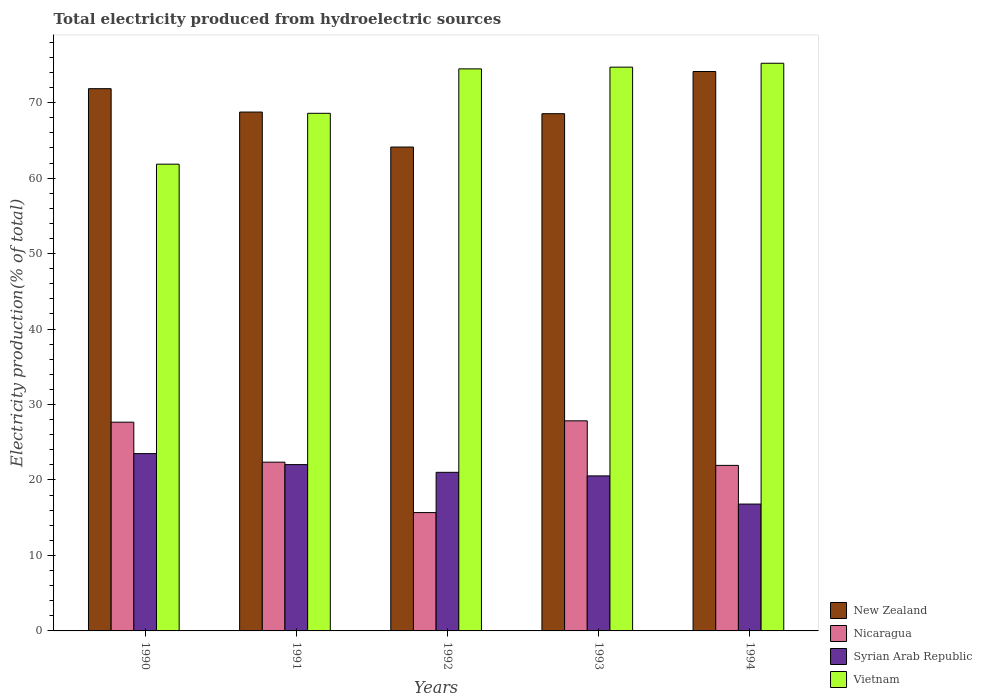How many different coloured bars are there?
Ensure brevity in your answer.  4. Are the number of bars on each tick of the X-axis equal?
Provide a succinct answer. Yes. How many bars are there on the 5th tick from the right?
Offer a very short reply. 4. What is the label of the 5th group of bars from the left?
Offer a very short reply. 1994. In how many cases, is the number of bars for a given year not equal to the number of legend labels?
Make the answer very short. 0. What is the total electricity produced in New Zealand in 1993?
Keep it short and to the point. 68.54. Across all years, what is the maximum total electricity produced in New Zealand?
Your answer should be compact. 74.13. Across all years, what is the minimum total electricity produced in New Zealand?
Give a very brief answer. 64.12. What is the total total electricity produced in Syrian Arab Republic in the graph?
Ensure brevity in your answer.  103.9. What is the difference between the total electricity produced in Nicaragua in 1990 and that in 1992?
Provide a succinct answer. 11.98. What is the difference between the total electricity produced in New Zealand in 1994 and the total electricity produced in Vietnam in 1990?
Provide a short and direct response. 12.28. What is the average total electricity produced in Nicaragua per year?
Give a very brief answer. 23.1. In the year 1993, what is the difference between the total electricity produced in Nicaragua and total electricity produced in Vietnam?
Ensure brevity in your answer.  -46.87. In how many years, is the total electricity produced in Syrian Arab Republic greater than 42 %?
Make the answer very short. 0. What is the ratio of the total electricity produced in New Zealand in 1992 to that in 1993?
Offer a very short reply. 0.94. What is the difference between the highest and the second highest total electricity produced in Syrian Arab Republic?
Keep it short and to the point. 1.46. What is the difference between the highest and the lowest total electricity produced in Nicaragua?
Ensure brevity in your answer.  12.16. In how many years, is the total electricity produced in Nicaragua greater than the average total electricity produced in Nicaragua taken over all years?
Your answer should be very brief. 2. Is the sum of the total electricity produced in Syrian Arab Republic in 1990 and 1992 greater than the maximum total electricity produced in Vietnam across all years?
Give a very brief answer. No. Is it the case that in every year, the sum of the total electricity produced in New Zealand and total electricity produced in Nicaragua is greater than the sum of total electricity produced in Vietnam and total electricity produced in Syrian Arab Republic?
Provide a succinct answer. No. What does the 2nd bar from the left in 1991 represents?
Provide a short and direct response. Nicaragua. What does the 1st bar from the right in 1993 represents?
Make the answer very short. Vietnam. How many years are there in the graph?
Provide a short and direct response. 5. Are the values on the major ticks of Y-axis written in scientific E-notation?
Ensure brevity in your answer.  No. Does the graph contain grids?
Provide a succinct answer. No. Where does the legend appear in the graph?
Give a very brief answer. Bottom right. How are the legend labels stacked?
Keep it short and to the point. Vertical. What is the title of the graph?
Offer a very short reply. Total electricity produced from hydroelectric sources. What is the label or title of the X-axis?
Make the answer very short. Years. What is the Electricity production(% of total) in New Zealand in 1990?
Offer a terse response. 71.85. What is the Electricity production(% of total) in Nicaragua in 1990?
Offer a very short reply. 27.66. What is the Electricity production(% of total) of Syrian Arab Republic in 1990?
Provide a short and direct response. 23.49. What is the Electricity production(% of total) of Vietnam in 1990?
Give a very brief answer. 61.85. What is the Electricity production(% of total) in New Zealand in 1991?
Offer a terse response. 68.75. What is the Electricity production(% of total) in Nicaragua in 1991?
Ensure brevity in your answer.  22.36. What is the Electricity production(% of total) in Syrian Arab Republic in 1991?
Your response must be concise. 22.04. What is the Electricity production(% of total) in Vietnam in 1991?
Your answer should be compact. 68.59. What is the Electricity production(% of total) of New Zealand in 1992?
Give a very brief answer. 64.12. What is the Electricity production(% of total) in Nicaragua in 1992?
Give a very brief answer. 15.68. What is the Electricity production(% of total) in Syrian Arab Republic in 1992?
Offer a very short reply. 21.02. What is the Electricity production(% of total) in Vietnam in 1992?
Provide a short and direct response. 74.48. What is the Electricity production(% of total) of New Zealand in 1993?
Make the answer very short. 68.54. What is the Electricity production(% of total) of Nicaragua in 1993?
Keep it short and to the point. 27.84. What is the Electricity production(% of total) in Syrian Arab Republic in 1993?
Make the answer very short. 20.54. What is the Electricity production(% of total) in Vietnam in 1993?
Keep it short and to the point. 74.7. What is the Electricity production(% of total) of New Zealand in 1994?
Provide a short and direct response. 74.13. What is the Electricity production(% of total) in Nicaragua in 1994?
Your response must be concise. 21.94. What is the Electricity production(% of total) of Syrian Arab Republic in 1994?
Provide a short and direct response. 16.81. What is the Electricity production(% of total) in Vietnam in 1994?
Offer a very short reply. 75.22. Across all years, what is the maximum Electricity production(% of total) of New Zealand?
Offer a very short reply. 74.13. Across all years, what is the maximum Electricity production(% of total) in Nicaragua?
Make the answer very short. 27.84. Across all years, what is the maximum Electricity production(% of total) in Syrian Arab Republic?
Make the answer very short. 23.49. Across all years, what is the maximum Electricity production(% of total) of Vietnam?
Your response must be concise. 75.22. Across all years, what is the minimum Electricity production(% of total) of New Zealand?
Give a very brief answer. 64.12. Across all years, what is the minimum Electricity production(% of total) in Nicaragua?
Your answer should be compact. 15.68. Across all years, what is the minimum Electricity production(% of total) of Syrian Arab Republic?
Your answer should be very brief. 16.81. Across all years, what is the minimum Electricity production(% of total) of Vietnam?
Offer a very short reply. 61.85. What is the total Electricity production(% of total) in New Zealand in the graph?
Ensure brevity in your answer.  347.39. What is the total Electricity production(% of total) of Nicaragua in the graph?
Provide a short and direct response. 115.48. What is the total Electricity production(% of total) in Syrian Arab Republic in the graph?
Ensure brevity in your answer.  103.9. What is the total Electricity production(% of total) in Vietnam in the graph?
Your answer should be compact. 354.84. What is the difference between the Electricity production(% of total) in New Zealand in 1990 and that in 1991?
Offer a very short reply. 3.1. What is the difference between the Electricity production(% of total) in Nicaragua in 1990 and that in 1991?
Offer a terse response. 5.3. What is the difference between the Electricity production(% of total) of Syrian Arab Republic in 1990 and that in 1991?
Provide a succinct answer. 1.46. What is the difference between the Electricity production(% of total) in Vietnam in 1990 and that in 1991?
Your answer should be very brief. -6.74. What is the difference between the Electricity production(% of total) in New Zealand in 1990 and that in 1992?
Make the answer very short. 7.73. What is the difference between the Electricity production(% of total) in Nicaragua in 1990 and that in 1992?
Give a very brief answer. 11.98. What is the difference between the Electricity production(% of total) of Syrian Arab Republic in 1990 and that in 1992?
Provide a succinct answer. 2.48. What is the difference between the Electricity production(% of total) in Vietnam in 1990 and that in 1992?
Provide a succinct answer. -12.63. What is the difference between the Electricity production(% of total) in New Zealand in 1990 and that in 1993?
Offer a terse response. 3.31. What is the difference between the Electricity production(% of total) of Nicaragua in 1990 and that in 1993?
Offer a very short reply. -0.18. What is the difference between the Electricity production(% of total) in Syrian Arab Republic in 1990 and that in 1993?
Give a very brief answer. 2.95. What is the difference between the Electricity production(% of total) in Vietnam in 1990 and that in 1993?
Your response must be concise. -12.86. What is the difference between the Electricity production(% of total) of New Zealand in 1990 and that in 1994?
Give a very brief answer. -2.28. What is the difference between the Electricity production(% of total) of Nicaragua in 1990 and that in 1994?
Ensure brevity in your answer.  5.72. What is the difference between the Electricity production(% of total) in Syrian Arab Republic in 1990 and that in 1994?
Offer a very short reply. 6.69. What is the difference between the Electricity production(% of total) in Vietnam in 1990 and that in 1994?
Your answer should be very brief. -13.37. What is the difference between the Electricity production(% of total) in New Zealand in 1991 and that in 1992?
Your answer should be compact. 4.63. What is the difference between the Electricity production(% of total) of Nicaragua in 1991 and that in 1992?
Ensure brevity in your answer.  6.68. What is the difference between the Electricity production(% of total) in Syrian Arab Republic in 1991 and that in 1992?
Your answer should be very brief. 1.02. What is the difference between the Electricity production(% of total) of Vietnam in 1991 and that in 1992?
Ensure brevity in your answer.  -5.89. What is the difference between the Electricity production(% of total) of New Zealand in 1991 and that in 1993?
Offer a very short reply. 0.22. What is the difference between the Electricity production(% of total) of Nicaragua in 1991 and that in 1993?
Give a very brief answer. -5.48. What is the difference between the Electricity production(% of total) in Syrian Arab Republic in 1991 and that in 1993?
Provide a short and direct response. 1.5. What is the difference between the Electricity production(% of total) in Vietnam in 1991 and that in 1993?
Give a very brief answer. -6.12. What is the difference between the Electricity production(% of total) of New Zealand in 1991 and that in 1994?
Your answer should be very brief. -5.37. What is the difference between the Electricity production(% of total) of Nicaragua in 1991 and that in 1994?
Offer a terse response. 0.43. What is the difference between the Electricity production(% of total) of Syrian Arab Republic in 1991 and that in 1994?
Offer a terse response. 5.23. What is the difference between the Electricity production(% of total) of Vietnam in 1991 and that in 1994?
Your response must be concise. -6.63. What is the difference between the Electricity production(% of total) in New Zealand in 1992 and that in 1993?
Ensure brevity in your answer.  -4.42. What is the difference between the Electricity production(% of total) in Nicaragua in 1992 and that in 1993?
Give a very brief answer. -12.16. What is the difference between the Electricity production(% of total) in Syrian Arab Republic in 1992 and that in 1993?
Your answer should be compact. 0.47. What is the difference between the Electricity production(% of total) of Vietnam in 1992 and that in 1993?
Your answer should be very brief. -0.23. What is the difference between the Electricity production(% of total) of New Zealand in 1992 and that in 1994?
Ensure brevity in your answer.  -10.01. What is the difference between the Electricity production(% of total) in Nicaragua in 1992 and that in 1994?
Provide a short and direct response. -6.26. What is the difference between the Electricity production(% of total) of Syrian Arab Republic in 1992 and that in 1994?
Provide a short and direct response. 4.21. What is the difference between the Electricity production(% of total) in Vietnam in 1992 and that in 1994?
Your response must be concise. -0.74. What is the difference between the Electricity production(% of total) in New Zealand in 1993 and that in 1994?
Your answer should be compact. -5.59. What is the difference between the Electricity production(% of total) of Nicaragua in 1993 and that in 1994?
Make the answer very short. 5.9. What is the difference between the Electricity production(% of total) of Syrian Arab Republic in 1993 and that in 1994?
Keep it short and to the point. 3.73. What is the difference between the Electricity production(% of total) of Vietnam in 1993 and that in 1994?
Offer a terse response. -0.52. What is the difference between the Electricity production(% of total) in New Zealand in 1990 and the Electricity production(% of total) in Nicaragua in 1991?
Your answer should be compact. 49.49. What is the difference between the Electricity production(% of total) in New Zealand in 1990 and the Electricity production(% of total) in Syrian Arab Republic in 1991?
Give a very brief answer. 49.81. What is the difference between the Electricity production(% of total) of New Zealand in 1990 and the Electricity production(% of total) of Vietnam in 1991?
Give a very brief answer. 3.26. What is the difference between the Electricity production(% of total) of Nicaragua in 1990 and the Electricity production(% of total) of Syrian Arab Republic in 1991?
Give a very brief answer. 5.62. What is the difference between the Electricity production(% of total) in Nicaragua in 1990 and the Electricity production(% of total) in Vietnam in 1991?
Make the answer very short. -40.93. What is the difference between the Electricity production(% of total) in Syrian Arab Republic in 1990 and the Electricity production(% of total) in Vietnam in 1991?
Your response must be concise. -45.09. What is the difference between the Electricity production(% of total) of New Zealand in 1990 and the Electricity production(% of total) of Nicaragua in 1992?
Keep it short and to the point. 56.17. What is the difference between the Electricity production(% of total) in New Zealand in 1990 and the Electricity production(% of total) in Syrian Arab Republic in 1992?
Keep it short and to the point. 50.84. What is the difference between the Electricity production(% of total) of New Zealand in 1990 and the Electricity production(% of total) of Vietnam in 1992?
Make the answer very short. -2.63. What is the difference between the Electricity production(% of total) of Nicaragua in 1990 and the Electricity production(% of total) of Syrian Arab Republic in 1992?
Keep it short and to the point. 6.64. What is the difference between the Electricity production(% of total) of Nicaragua in 1990 and the Electricity production(% of total) of Vietnam in 1992?
Provide a succinct answer. -46.82. What is the difference between the Electricity production(% of total) in Syrian Arab Republic in 1990 and the Electricity production(% of total) in Vietnam in 1992?
Make the answer very short. -50.98. What is the difference between the Electricity production(% of total) of New Zealand in 1990 and the Electricity production(% of total) of Nicaragua in 1993?
Give a very brief answer. 44.01. What is the difference between the Electricity production(% of total) in New Zealand in 1990 and the Electricity production(% of total) in Syrian Arab Republic in 1993?
Provide a succinct answer. 51.31. What is the difference between the Electricity production(% of total) of New Zealand in 1990 and the Electricity production(% of total) of Vietnam in 1993?
Keep it short and to the point. -2.85. What is the difference between the Electricity production(% of total) of Nicaragua in 1990 and the Electricity production(% of total) of Syrian Arab Republic in 1993?
Provide a short and direct response. 7.12. What is the difference between the Electricity production(% of total) of Nicaragua in 1990 and the Electricity production(% of total) of Vietnam in 1993?
Offer a terse response. -47.05. What is the difference between the Electricity production(% of total) of Syrian Arab Republic in 1990 and the Electricity production(% of total) of Vietnam in 1993?
Ensure brevity in your answer.  -51.21. What is the difference between the Electricity production(% of total) in New Zealand in 1990 and the Electricity production(% of total) in Nicaragua in 1994?
Offer a very short reply. 49.92. What is the difference between the Electricity production(% of total) of New Zealand in 1990 and the Electricity production(% of total) of Syrian Arab Republic in 1994?
Give a very brief answer. 55.04. What is the difference between the Electricity production(% of total) in New Zealand in 1990 and the Electricity production(% of total) in Vietnam in 1994?
Your response must be concise. -3.37. What is the difference between the Electricity production(% of total) of Nicaragua in 1990 and the Electricity production(% of total) of Syrian Arab Republic in 1994?
Make the answer very short. 10.85. What is the difference between the Electricity production(% of total) in Nicaragua in 1990 and the Electricity production(% of total) in Vietnam in 1994?
Give a very brief answer. -47.56. What is the difference between the Electricity production(% of total) of Syrian Arab Republic in 1990 and the Electricity production(% of total) of Vietnam in 1994?
Keep it short and to the point. -51.72. What is the difference between the Electricity production(% of total) of New Zealand in 1991 and the Electricity production(% of total) of Nicaragua in 1992?
Provide a succinct answer. 53.07. What is the difference between the Electricity production(% of total) in New Zealand in 1991 and the Electricity production(% of total) in Syrian Arab Republic in 1992?
Your answer should be compact. 47.74. What is the difference between the Electricity production(% of total) in New Zealand in 1991 and the Electricity production(% of total) in Vietnam in 1992?
Keep it short and to the point. -5.72. What is the difference between the Electricity production(% of total) in Nicaragua in 1991 and the Electricity production(% of total) in Syrian Arab Republic in 1992?
Offer a very short reply. 1.35. What is the difference between the Electricity production(% of total) of Nicaragua in 1991 and the Electricity production(% of total) of Vietnam in 1992?
Ensure brevity in your answer.  -52.11. What is the difference between the Electricity production(% of total) in Syrian Arab Republic in 1991 and the Electricity production(% of total) in Vietnam in 1992?
Ensure brevity in your answer.  -52.44. What is the difference between the Electricity production(% of total) of New Zealand in 1991 and the Electricity production(% of total) of Nicaragua in 1993?
Give a very brief answer. 40.91. What is the difference between the Electricity production(% of total) in New Zealand in 1991 and the Electricity production(% of total) in Syrian Arab Republic in 1993?
Your answer should be compact. 48.21. What is the difference between the Electricity production(% of total) in New Zealand in 1991 and the Electricity production(% of total) in Vietnam in 1993?
Offer a very short reply. -5.95. What is the difference between the Electricity production(% of total) of Nicaragua in 1991 and the Electricity production(% of total) of Syrian Arab Republic in 1993?
Your answer should be very brief. 1.82. What is the difference between the Electricity production(% of total) of Nicaragua in 1991 and the Electricity production(% of total) of Vietnam in 1993?
Your answer should be compact. -52.34. What is the difference between the Electricity production(% of total) of Syrian Arab Republic in 1991 and the Electricity production(% of total) of Vietnam in 1993?
Make the answer very short. -52.67. What is the difference between the Electricity production(% of total) of New Zealand in 1991 and the Electricity production(% of total) of Nicaragua in 1994?
Your response must be concise. 46.82. What is the difference between the Electricity production(% of total) of New Zealand in 1991 and the Electricity production(% of total) of Syrian Arab Republic in 1994?
Your answer should be very brief. 51.94. What is the difference between the Electricity production(% of total) in New Zealand in 1991 and the Electricity production(% of total) in Vietnam in 1994?
Give a very brief answer. -6.47. What is the difference between the Electricity production(% of total) of Nicaragua in 1991 and the Electricity production(% of total) of Syrian Arab Republic in 1994?
Your response must be concise. 5.55. What is the difference between the Electricity production(% of total) of Nicaragua in 1991 and the Electricity production(% of total) of Vietnam in 1994?
Ensure brevity in your answer.  -52.86. What is the difference between the Electricity production(% of total) of Syrian Arab Republic in 1991 and the Electricity production(% of total) of Vietnam in 1994?
Keep it short and to the point. -53.18. What is the difference between the Electricity production(% of total) in New Zealand in 1992 and the Electricity production(% of total) in Nicaragua in 1993?
Make the answer very short. 36.28. What is the difference between the Electricity production(% of total) in New Zealand in 1992 and the Electricity production(% of total) in Syrian Arab Republic in 1993?
Provide a short and direct response. 43.58. What is the difference between the Electricity production(% of total) in New Zealand in 1992 and the Electricity production(% of total) in Vietnam in 1993?
Your answer should be very brief. -10.59. What is the difference between the Electricity production(% of total) in Nicaragua in 1992 and the Electricity production(% of total) in Syrian Arab Republic in 1993?
Offer a very short reply. -4.86. What is the difference between the Electricity production(% of total) of Nicaragua in 1992 and the Electricity production(% of total) of Vietnam in 1993?
Offer a terse response. -59.02. What is the difference between the Electricity production(% of total) of Syrian Arab Republic in 1992 and the Electricity production(% of total) of Vietnam in 1993?
Offer a very short reply. -53.69. What is the difference between the Electricity production(% of total) in New Zealand in 1992 and the Electricity production(% of total) in Nicaragua in 1994?
Offer a terse response. 42.18. What is the difference between the Electricity production(% of total) of New Zealand in 1992 and the Electricity production(% of total) of Syrian Arab Republic in 1994?
Offer a very short reply. 47.31. What is the difference between the Electricity production(% of total) of New Zealand in 1992 and the Electricity production(% of total) of Vietnam in 1994?
Offer a very short reply. -11.1. What is the difference between the Electricity production(% of total) in Nicaragua in 1992 and the Electricity production(% of total) in Syrian Arab Republic in 1994?
Keep it short and to the point. -1.13. What is the difference between the Electricity production(% of total) in Nicaragua in 1992 and the Electricity production(% of total) in Vietnam in 1994?
Make the answer very short. -59.54. What is the difference between the Electricity production(% of total) of Syrian Arab Republic in 1992 and the Electricity production(% of total) of Vietnam in 1994?
Offer a terse response. -54.2. What is the difference between the Electricity production(% of total) of New Zealand in 1993 and the Electricity production(% of total) of Nicaragua in 1994?
Give a very brief answer. 46.6. What is the difference between the Electricity production(% of total) of New Zealand in 1993 and the Electricity production(% of total) of Syrian Arab Republic in 1994?
Make the answer very short. 51.73. What is the difference between the Electricity production(% of total) of New Zealand in 1993 and the Electricity production(% of total) of Vietnam in 1994?
Your answer should be compact. -6.68. What is the difference between the Electricity production(% of total) in Nicaragua in 1993 and the Electricity production(% of total) in Syrian Arab Republic in 1994?
Provide a short and direct response. 11.03. What is the difference between the Electricity production(% of total) of Nicaragua in 1993 and the Electricity production(% of total) of Vietnam in 1994?
Provide a succinct answer. -47.38. What is the difference between the Electricity production(% of total) of Syrian Arab Republic in 1993 and the Electricity production(% of total) of Vietnam in 1994?
Keep it short and to the point. -54.68. What is the average Electricity production(% of total) of New Zealand per year?
Offer a very short reply. 69.48. What is the average Electricity production(% of total) in Nicaragua per year?
Make the answer very short. 23.1. What is the average Electricity production(% of total) of Syrian Arab Republic per year?
Your answer should be very brief. 20.78. What is the average Electricity production(% of total) in Vietnam per year?
Keep it short and to the point. 70.97. In the year 1990, what is the difference between the Electricity production(% of total) in New Zealand and Electricity production(% of total) in Nicaragua?
Your answer should be very brief. 44.19. In the year 1990, what is the difference between the Electricity production(% of total) of New Zealand and Electricity production(% of total) of Syrian Arab Republic?
Your answer should be very brief. 48.36. In the year 1990, what is the difference between the Electricity production(% of total) in New Zealand and Electricity production(% of total) in Vietnam?
Provide a succinct answer. 10. In the year 1990, what is the difference between the Electricity production(% of total) in Nicaragua and Electricity production(% of total) in Syrian Arab Republic?
Your answer should be very brief. 4.16. In the year 1990, what is the difference between the Electricity production(% of total) in Nicaragua and Electricity production(% of total) in Vietnam?
Offer a terse response. -34.19. In the year 1990, what is the difference between the Electricity production(% of total) of Syrian Arab Republic and Electricity production(% of total) of Vietnam?
Make the answer very short. -38.35. In the year 1991, what is the difference between the Electricity production(% of total) in New Zealand and Electricity production(% of total) in Nicaragua?
Give a very brief answer. 46.39. In the year 1991, what is the difference between the Electricity production(% of total) of New Zealand and Electricity production(% of total) of Syrian Arab Republic?
Offer a terse response. 46.72. In the year 1991, what is the difference between the Electricity production(% of total) of New Zealand and Electricity production(% of total) of Vietnam?
Make the answer very short. 0.16. In the year 1991, what is the difference between the Electricity production(% of total) of Nicaragua and Electricity production(% of total) of Syrian Arab Republic?
Your answer should be very brief. 0.32. In the year 1991, what is the difference between the Electricity production(% of total) in Nicaragua and Electricity production(% of total) in Vietnam?
Ensure brevity in your answer.  -46.23. In the year 1991, what is the difference between the Electricity production(% of total) in Syrian Arab Republic and Electricity production(% of total) in Vietnam?
Give a very brief answer. -46.55. In the year 1992, what is the difference between the Electricity production(% of total) in New Zealand and Electricity production(% of total) in Nicaragua?
Your answer should be compact. 48.44. In the year 1992, what is the difference between the Electricity production(% of total) of New Zealand and Electricity production(% of total) of Syrian Arab Republic?
Your answer should be compact. 43.1. In the year 1992, what is the difference between the Electricity production(% of total) in New Zealand and Electricity production(% of total) in Vietnam?
Offer a terse response. -10.36. In the year 1992, what is the difference between the Electricity production(% of total) of Nicaragua and Electricity production(% of total) of Syrian Arab Republic?
Keep it short and to the point. -5.34. In the year 1992, what is the difference between the Electricity production(% of total) of Nicaragua and Electricity production(% of total) of Vietnam?
Your answer should be very brief. -58.8. In the year 1992, what is the difference between the Electricity production(% of total) in Syrian Arab Republic and Electricity production(% of total) in Vietnam?
Offer a very short reply. -53.46. In the year 1993, what is the difference between the Electricity production(% of total) of New Zealand and Electricity production(% of total) of Nicaragua?
Make the answer very short. 40.7. In the year 1993, what is the difference between the Electricity production(% of total) of New Zealand and Electricity production(% of total) of Syrian Arab Republic?
Your response must be concise. 48. In the year 1993, what is the difference between the Electricity production(% of total) of New Zealand and Electricity production(% of total) of Vietnam?
Keep it short and to the point. -6.17. In the year 1993, what is the difference between the Electricity production(% of total) in Nicaragua and Electricity production(% of total) in Syrian Arab Republic?
Offer a very short reply. 7.3. In the year 1993, what is the difference between the Electricity production(% of total) of Nicaragua and Electricity production(% of total) of Vietnam?
Give a very brief answer. -46.87. In the year 1993, what is the difference between the Electricity production(% of total) in Syrian Arab Republic and Electricity production(% of total) in Vietnam?
Provide a short and direct response. -54.16. In the year 1994, what is the difference between the Electricity production(% of total) in New Zealand and Electricity production(% of total) in Nicaragua?
Your answer should be very brief. 52.19. In the year 1994, what is the difference between the Electricity production(% of total) of New Zealand and Electricity production(% of total) of Syrian Arab Republic?
Your answer should be very brief. 57.32. In the year 1994, what is the difference between the Electricity production(% of total) of New Zealand and Electricity production(% of total) of Vietnam?
Your response must be concise. -1.09. In the year 1994, what is the difference between the Electricity production(% of total) of Nicaragua and Electricity production(% of total) of Syrian Arab Republic?
Your answer should be compact. 5.13. In the year 1994, what is the difference between the Electricity production(% of total) in Nicaragua and Electricity production(% of total) in Vietnam?
Provide a short and direct response. -53.28. In the year 1994, what is the difference between the Electricity production(% of total) in Syrian Arab Republic and Electricity production(% of total) in Vietnam?
Offer a terse response. -58.41. What is the ratio of the Electricity production(% of total) in New Zealand in 1990 to that in 1991?
Offer a very short reply. 1.05. What is the ratio of the Electricity production(% of total) of Nicaragua in 1990 to that in 1991?
Offer a terse response. 1.24. What is the ratio of the Electricity production(% of total) in Syrian Arab Republic in 1990 to that in 1991?
Provide a short and direct response. 1.07. What is the ratio of the Electricity production(% of total) in Vietnam in 1990 to that in 1991?
Your answer should be very brief. 0.9. What is the ratio of the Electricity production(% of total) in New Zealand in 1990 to that in 1992?
Your response must be concise. 1.12. What is the ratio of the Electricity production(% of total) in Nicaragua in 1990 to that in 1992?
Your response must be concise. 1.76. What is the ratio of the Electricity production(% of total) in Syrian Arab Republic in 1990 to that in 1992?
Make the answer very short. 1.12. What is the ratio of the Electricity production(% of total) of Vietnam in 1990 to that in 1992?
Ensure brevity in your answer.  0.83. What is the ratio of the Electricity production(% of total) in New Zealand in 1990 to that in 1993?
Provide a short and direct response. 1.05. What is the ratio of the Electricity production(% of total) of Syrian Arab Republic in 1990 to that in 1993?
Offer a very short reply. 1.14. What is the ratio of the Electricity production(% of total) of Vietnam in 1990 to that in 1993?
Make the answer very short. 0.83. What is the ratio of the Electricity production(% of total) in New Zealand in 1990 to that in 1994?
Offer a terse response. 0.97. What is the ratio of the Electricity production(% of total) in Nicaragua in 1990 to that in 1994?
Make the answer very short. 1.26. What is the ratio of the Electricity production(% of total) of Syrian Arab Republic in 1990 to that in 1994?
Provide a succinct answer. 1.4. What is the ratio of the Electricity production(% of total) of Vietnam in 1990 to that in 1994?
Your response must be concise. 0.82. What is the ratio of the Electricity production(% of total) in New Zealand in 1991 to that in 1992?
Offer a very short reply. 1.07. What is the ratio of the Electricity production(% of total) of Nicaragua in 1991 to that in 1992?
Give a very brief answer. 1.43. What is the ratio of the Electricity production(% of total) of Syrian Arab Republic in 1991 to that in 1992?
Offer a very short reply. 1.05. What is the ratio of the Electricity production(% of total) in Vietnam in 1991 to that in 1992?
Keep it short and to the point. 0.92. What is the ratio of the Electricity production(% of total) in New Zealand in 1991 to that in 1993?
Offer a terse response. 1. What is the ratio of the Electricity production(% of total) of Nicaragua in 1991 to that in 1993?
Keep it short and to the point. 0.8. What is the ratio of the Electricity production(% of total) in Syrian Arab Republic in 1991 to that in 1993?
Your answer should be very brief. 1.07. What is the ratio of the Electricity production(% of total) of Vietnam in 1991 to that in 1993?
Keep it short and to the point. 0.92. What is the ratio of the Electricity production(% of total) in New Zealand in 1991 to that in 1994?
Provide a succinct answer. 0.93. What is the ratio of the Electricity production(% of total) in Nicaragua in 1991 to that in 1994?
Your answer should be very brief. 1.02. What is the ratio of the Electricity production(% of total) of Syrian Arab Republic in 1991 to that in 1994?
Make the answer very short. 1.31. What is the ratio of the Electricity production(% of total) in Vietnam in 1991 to that in 1994?
Provide a short and direct response. 0.91. What is the ratio of the Electricity production(% of total) in New Zealand in 1992 to that in 1993?
Your answer should be compact. 0.94. What is the ratio of the Electricity production(% of total) in Nicaragua in 1992 to that in 1993?
Keep it short and to the point. 0.56. What is the ratio of the Electricity production(% of total) in Syrian Arab Republic in 1992 to that in 1993?
Provide a succinct answer. 1.02. What is the ratio of the Electricity production(% of total) in Vietnam in 1992 to that in 1993?
Your answer should be compact. 1. What is the ratio of the Electricity production(% of total) of New Zealand in 1992 to that in 1994?
Provide a succinct answer. 0.86. What is the ratio of the Electricity production(% of total) in Nicaragua in 1992 to that in 1994?
Keep it short and to the point. 0.71. What is the ratio of the Electricity production(% of total) in Syrian Arab Republic in 1992 to that in 1994?
Keep it short and to the point. 1.25. What is the ratio of the Electricity production(% of total) of Vietnam in 1992 to that in 1994?
Make the answer very short. 0.99. What is the ratio of the Electricity production(% of total) in New Zealand in 1993 to that in 1994?
Give a very brief answer. 0.92. What is the ratio of the Electricity production(% of total) of Nicaragua in 1993 to that in 1994?
Your response must be concise. 1.27. What is the ratio of the Electricity production(% of total) in Syrian Arab Republic in 1993 to that in 1994?
Offer a very short reply. 1.22. What is the difference between the highest and the second highest Electricity production(% of total) of New Zealand?
Provide a succinct answer. 2.28. What is the difference between the highest and the second highest Electricity production(% of total) in Nicaragua?
Your answer should be very brief. 0.18. What is the difference between the highest and the second highest Electricity production(% of total) of Syrian Arab Republic?
Make the answer very short. 1.46. What is the difference between the highest and the second highest Electricity production(% of total) of Vietnam?
Your answer should be compact. 0.52. What is the difference between the highest and the lowest Electricity production(% of total) of New Zealand?
Offer a terse response. 10.01. What is the difference between the highest and the lowest Electricity production(% of total) in Nicaragua?
Provide a short and direct response. 12.16. What is the difference between the highest and the lowest Electricity production(% of total) of Syrian Arab Republic?
Ensure brevity in your answer.  6.69. What is the difference between the highest and the lowest Electricity production(% of total) of Vietnam?
Offer a terse response. 13.37. 